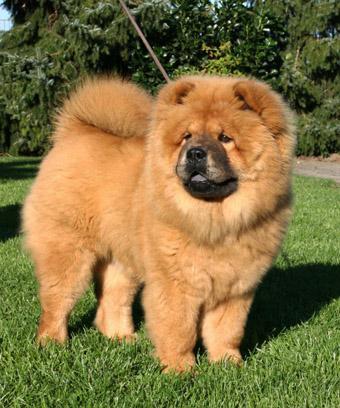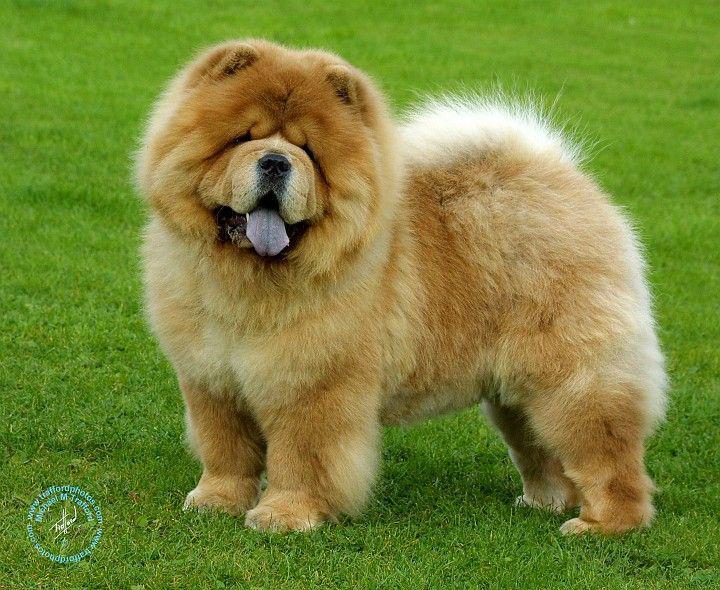The first image is the image on the left, the second image is the image on the right. Evaluate the accuracy of this statement regarding the images: "Two dogs are standing on the grass". Is it true? Answer yes or no. Yes. 